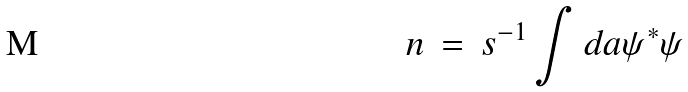<formula> <loc_0><loc_0><loc_500><loc_500>n \, = \, s ^ { - 1 } \int d a \psi ^ { \ast } \psi</formula> 